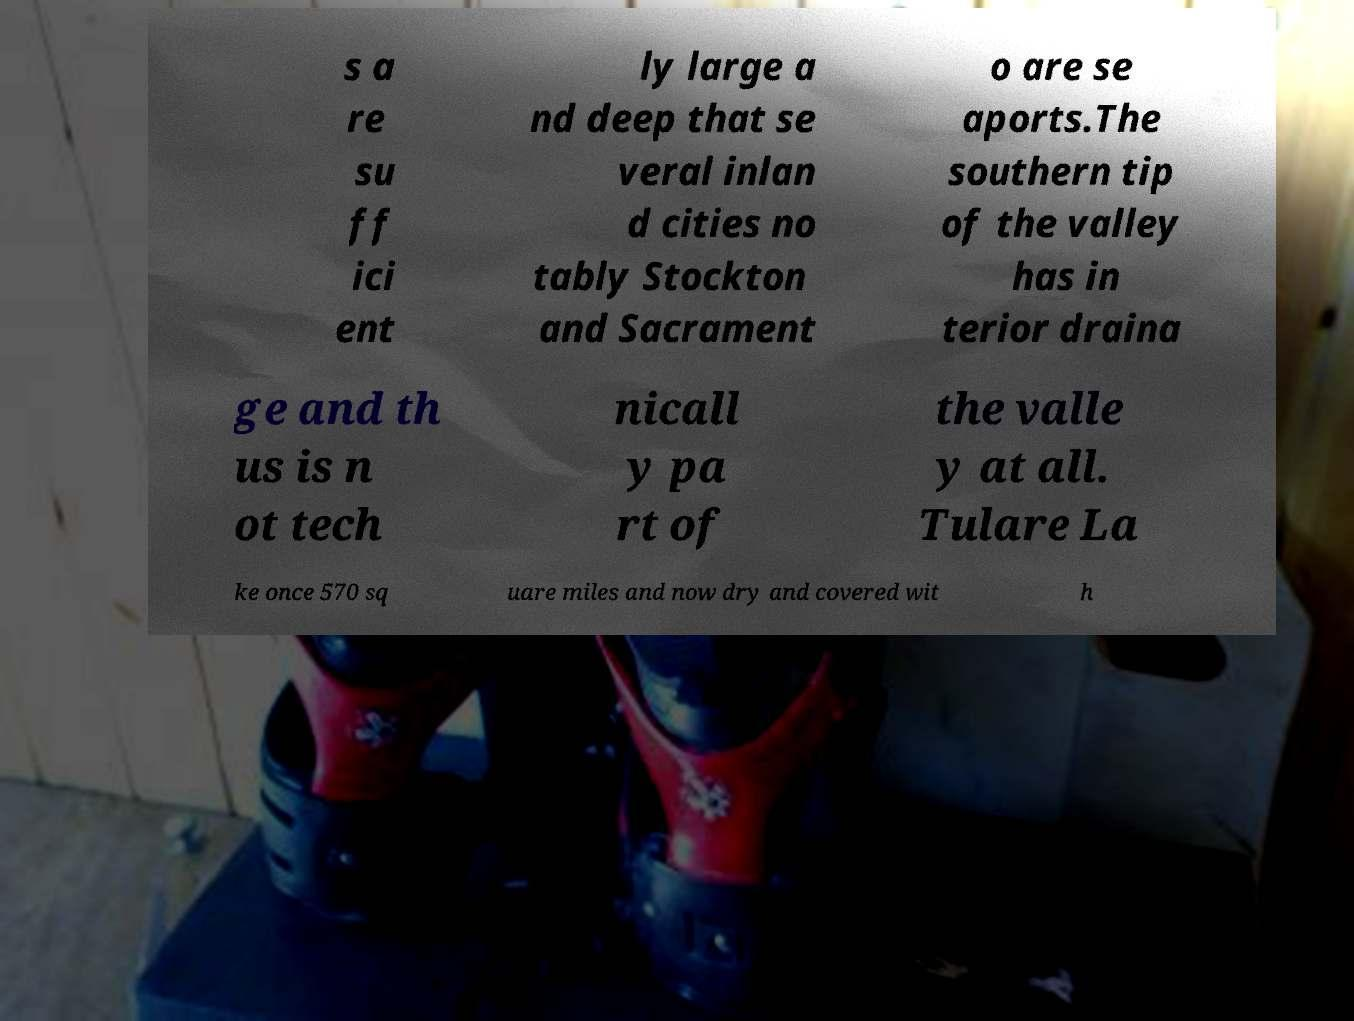I need the written content from this picture converted into text. Can you do that? s a re su ff ici ent ly large a nd deep that se veral inlan d cities no tably Stockton and Sacrament o are se aports.The southern tip of the valley has in terior draina ge and th us is n ot tech nicall y pa rt of the valle y at all. Tulare La ke once 570 sq uare miles and now dry and covered wit h 